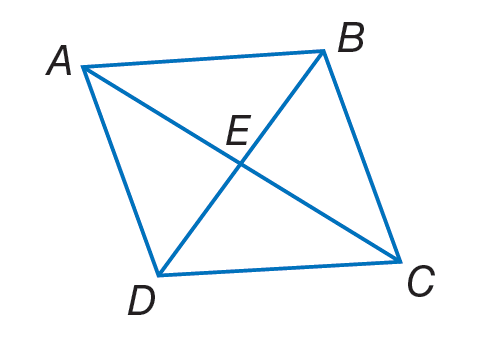Answer the mathemtical geometry problem and directly provide the correct option letter.
Question: A B C D is a rhombus. If E B = 9, A B = 12 and m \angle A B D = 55. Find m \angle B D A.
Choices: A: 9 B: 12 C: 20 D: 55 D 